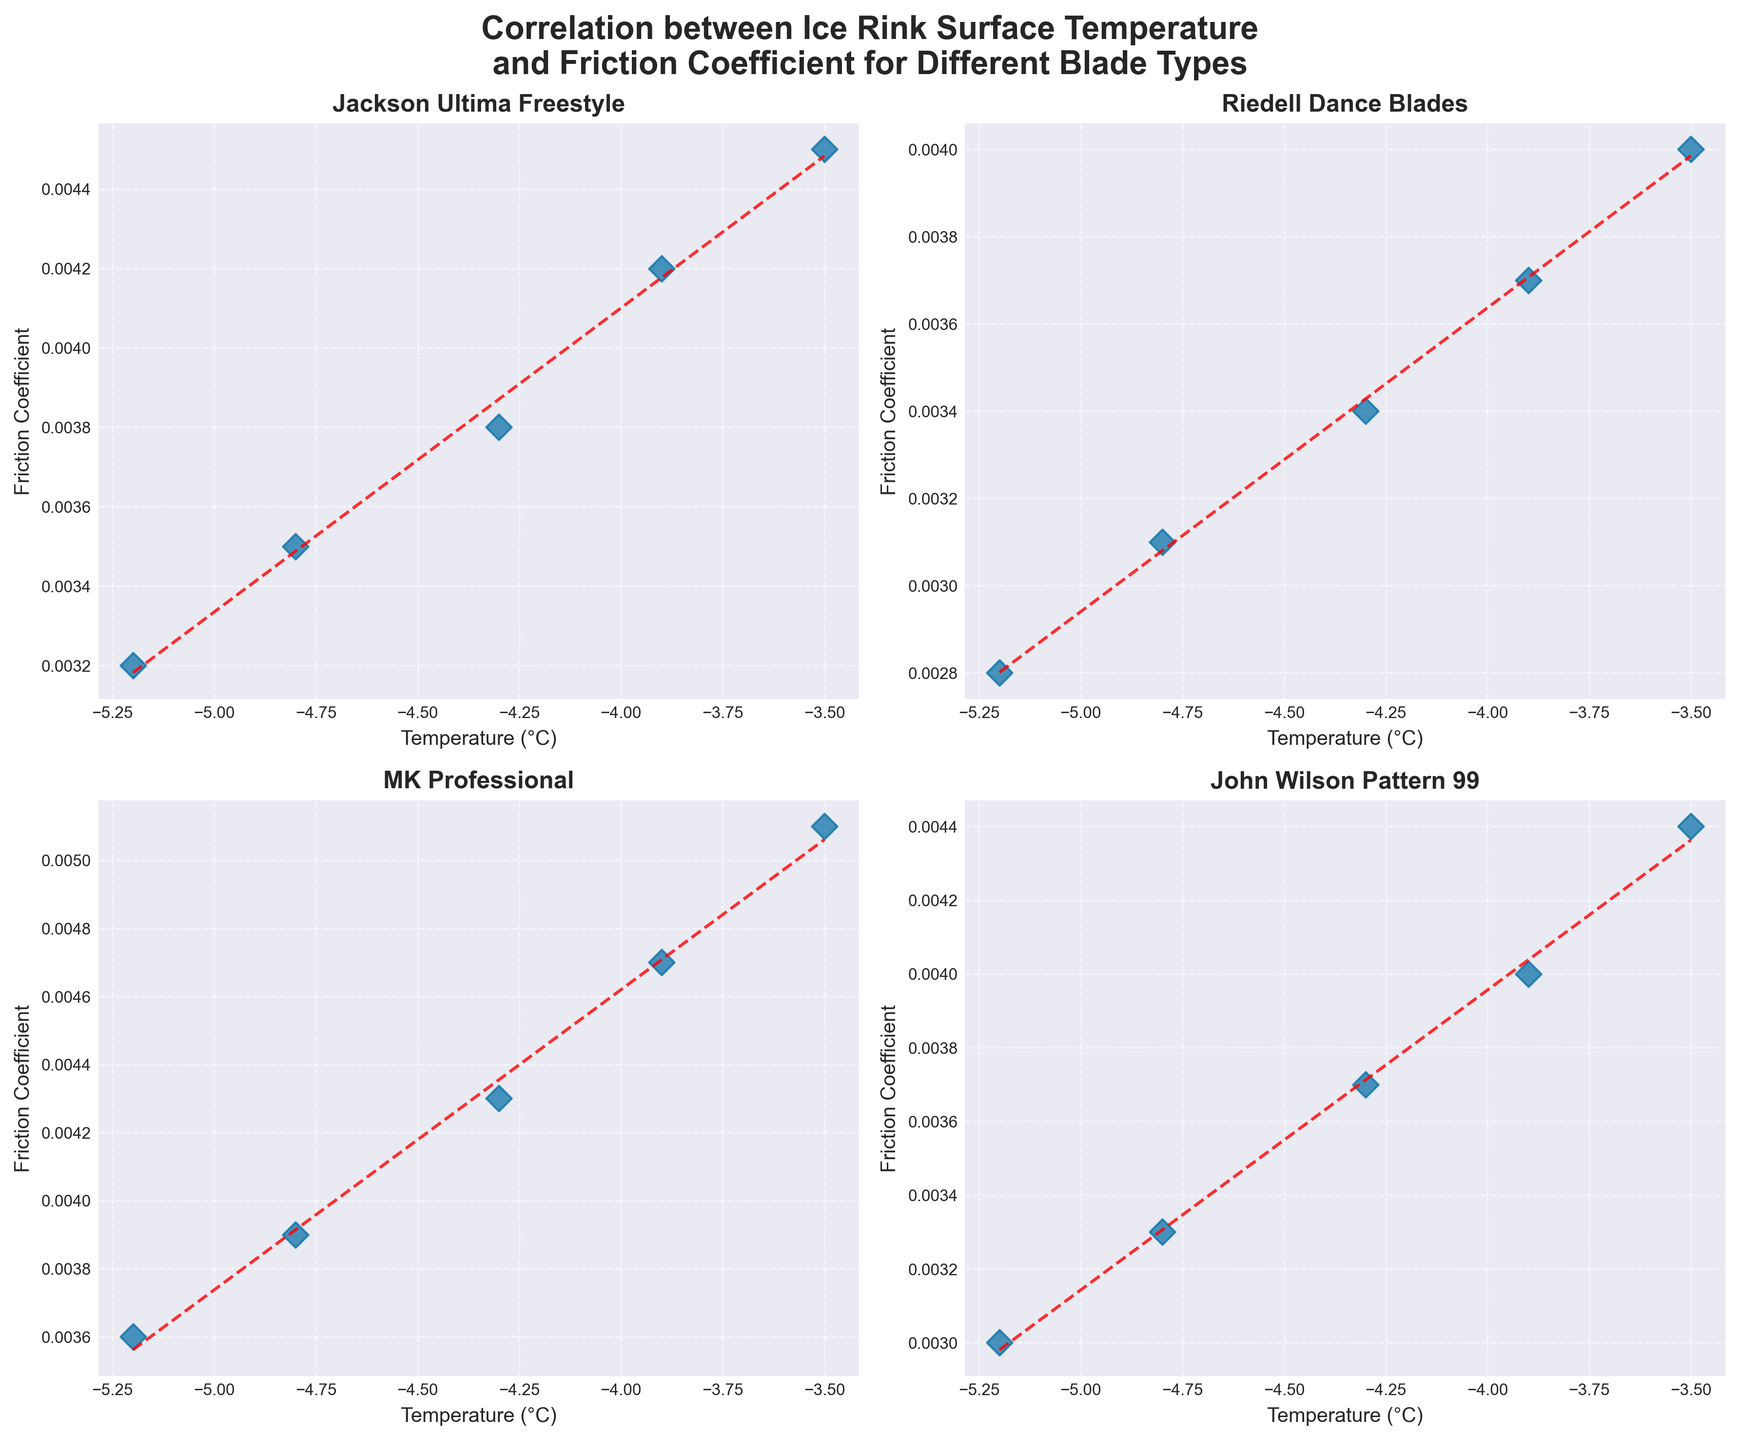What is the title of the figure? The title is displayed at the top of the figure, appearing in bold text. It reads "Correlation between Ice Rink Surface Temperature and Friction Coefficient for Different Blade Types"
Answer: Correlation between Ice Rink Surface Temperature and Friction Coefficient for Different Blade Types What is the range of temperatures shown in the subplot for "Jackson Ultima Freestyle"? Looking at the x-axis labels on the plot for "Jackson Ultima Freestyle", the temperature spans from -5.2°C to -3.5°C
Answer: -5.2°C to -3.5°C Which blade type has the highest friction coefficient at -3.5°C? By observing the points at -3.5°C across all subplots, the highest friction coefficient belongs to "MK Professional" with a value of 0.0051, as seen on the y-axis
Answer: MK Professional What is the overall trend between temperature and friction coefficient for "Riedell Dance Blades"? Analyzing the scatter plot and the trend line for "Riedell Dance Blades", it shows that as temperature increases, the friction coefficient also increases
Answer: As temperature increases, friction coefficient increases Which blade type shows the steepest increase in friction coefficient as temperature rises? By comparing the slopes of the trend lines across all subplots, "MK Professional" shows the steepest increase in the friction coefficient as temperature rises, indicated by the sharpest slope of its trend line
Answer: MK Professional How many blade types are compared in this figure? The figure consists of four subplots, each uniquely titled with a blade type. Therefore, four blade types are compared in this figure
Answer: Four At -4.3°C, which blade type has the lowest friction coefficient? Moving along the -4.3°C mark in all subplots, the "Riedell Dance Blades" has the lowest friction coefficient with a value of 0.0034
Answer: Riedell Dance Blades Does "John Wilson Pattern 99" show any outliers in its data? Examining the scatter plot for "John Wilson Pattern 99," the data points form a linear pattern along the trend line without any noticeable deviations or outliers
Answer: No Rank the blade types from the one with the highest friction coefficient at -5.2°C to the lowest Checking each subplot at temperature -5.2°C, the ranking from highest to lowest friction coefficient is: MK Professional (0.0036), Jackson Ultima Freestyle (0.0032), John Wilson Pattern 99 (0.0030), Riedell Dance Blades (0.0028)
Answer: MK Professional, Jackson Ultima Freestyle, John Wilson Pattern 99, Riedell Dance Blades 